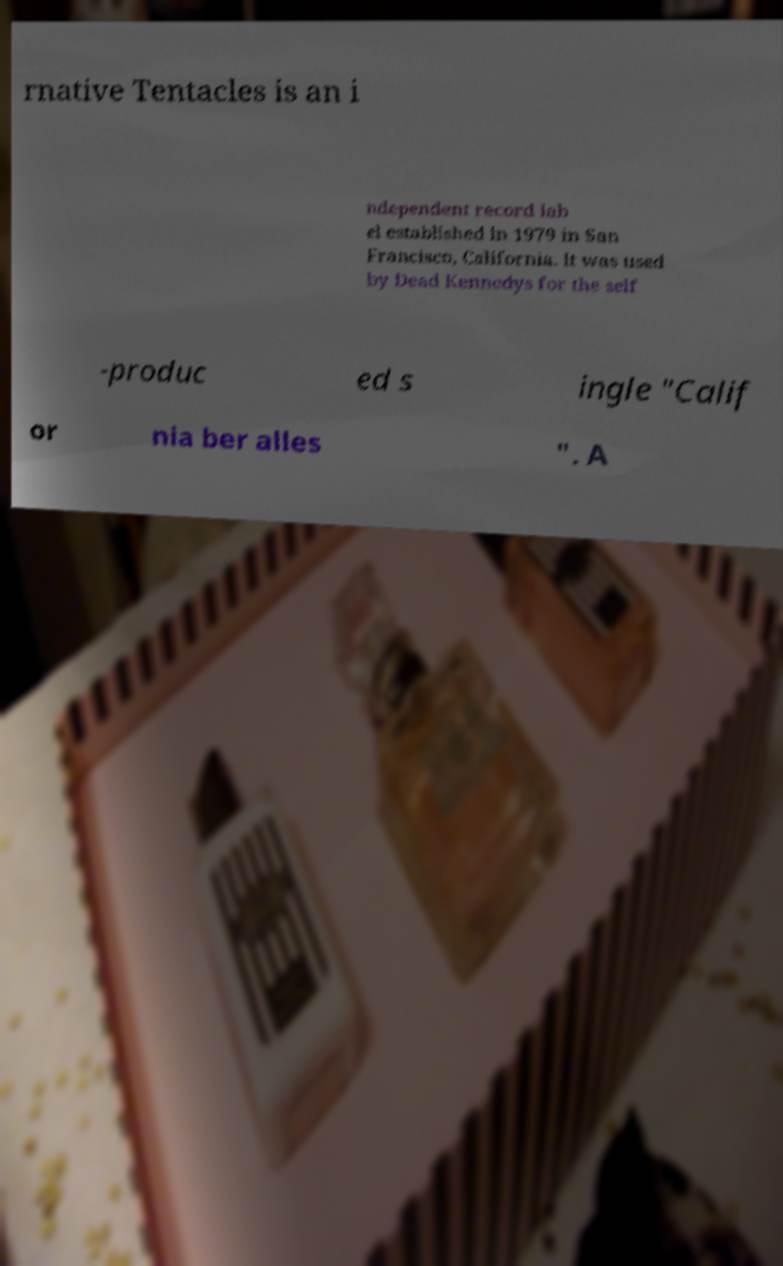For documentation purposes, I need the text within this image transcribed. Could you provide that? rnative Tentacles is an i ndependent record lab el established in 1979 in San Francisco, California. It was used by Dead Kennedys for the self -produc ed s ingle "Calif or nia ber alles ". A 